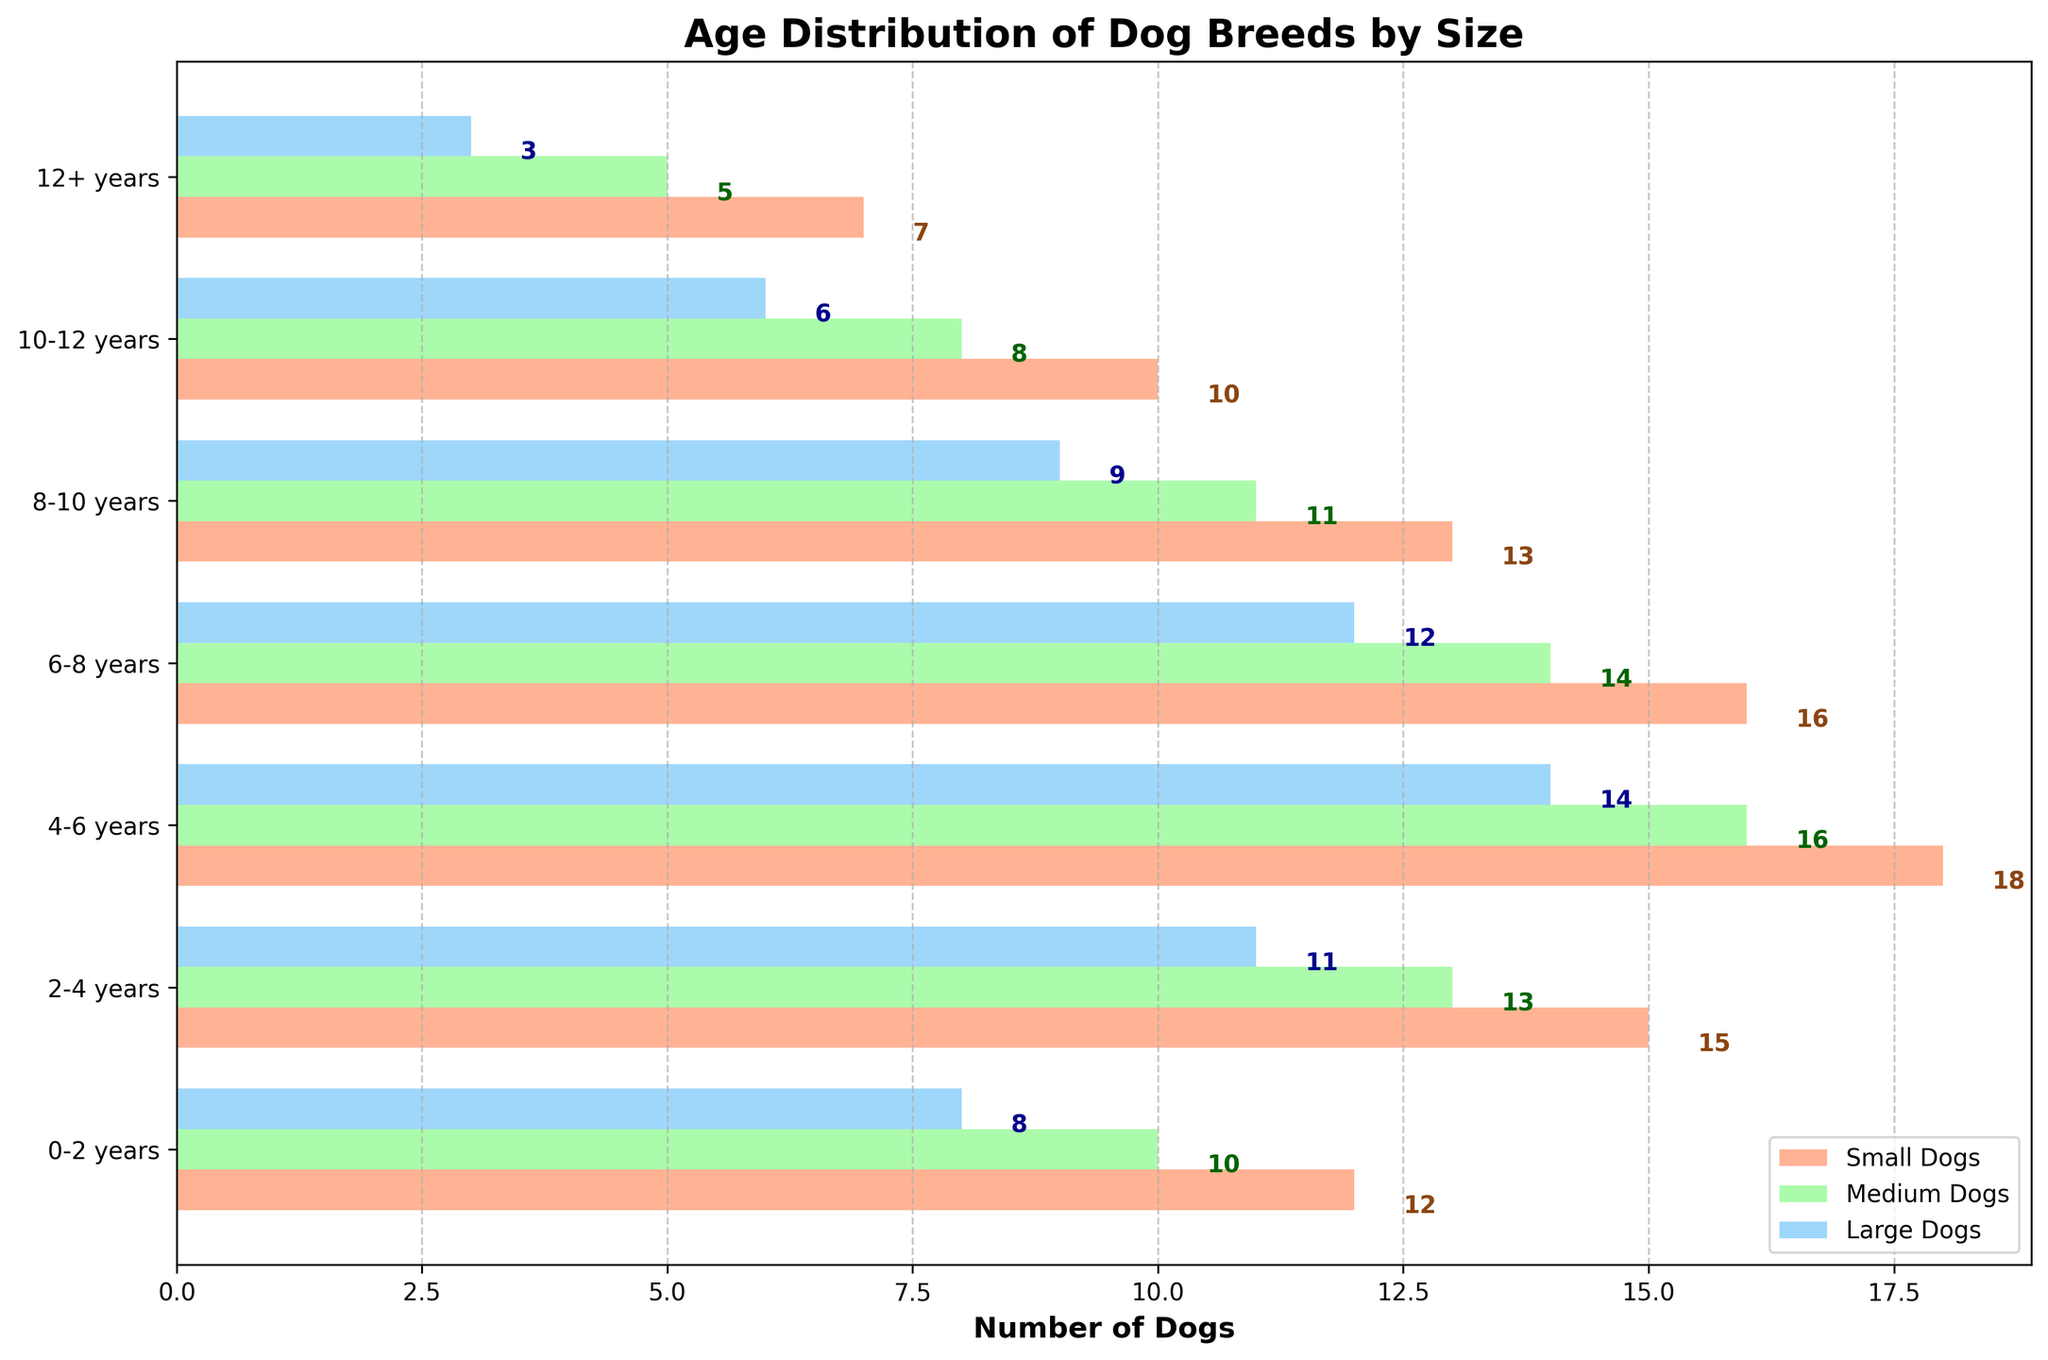What is the age range with the highest number of small dogs? The age range with the highest number of small dogs can be identified by finding the tallest bar specific to the color representing small dogs in the plot.
Answer: 4-6 years Which size category has the most dogs in the 6-8 years age range? To determine the size category with the most dogs in the 6-8 years age range, compare the heights of the bars corresponding to small, medium, and large dogs for that age range.
Answer: Small Dogs What is the total number of dogs between ages 2-6 years across all size categories? Add the number of small, medium, and large dogs together in the 2-4 years and 4-6 years age ranges: (15 + 13 + 11) + (18 + 16 + 14) = 39 + 48
Answer: 87 Which size category visibly decreases the most in number after the 8-10 years age range? Compare how much the number decreases for each size category from the 8-10 years age range to the next category (10-12 years). Check the difference between the bars.
Answer: Small Dogs Do medium-sized dogs generally outnumber large dogs in each age range? Look at each age range and compare the heights of the bars representing medium dogs and large dogs. If the medium dogs bars are consistently taller, it means they outnumber large dogs generally in each range.
Answer: Yes In which age range is the difference between the number of small dogs and large dogs the greatest? For each age range, calculate the difference between the number of small dogs and large dogs. Find the age range with the largest difference.
(12-8=4), (15-11=4), (18-14=4), (16-12=4), (13-9=4), (10-6=4), (7-3=4)
Answer: All Have Same Difference (4) What is the combined number of medium and large dogs in the oldest age range (12+ years)? Add the numbers of medium and large dogs in the 12+ years age range: (5 + 3) = 8.
Answer: 8 How does the trend of large dogs compare with that of small dogs as the age range increases? Observe the changing heights of bars for large dogs and small dogs from the youngest to the oldest age ranges. Note whether both trends increase, decrease, or show a different pattern.
Answer: Both Decrease At which age range does the number of small dogs start decreasing? Observe the heights of the bars for small dogs and identify the age range where the value starts to decrease compared to the previous age range.
Answer: 6-8 years 